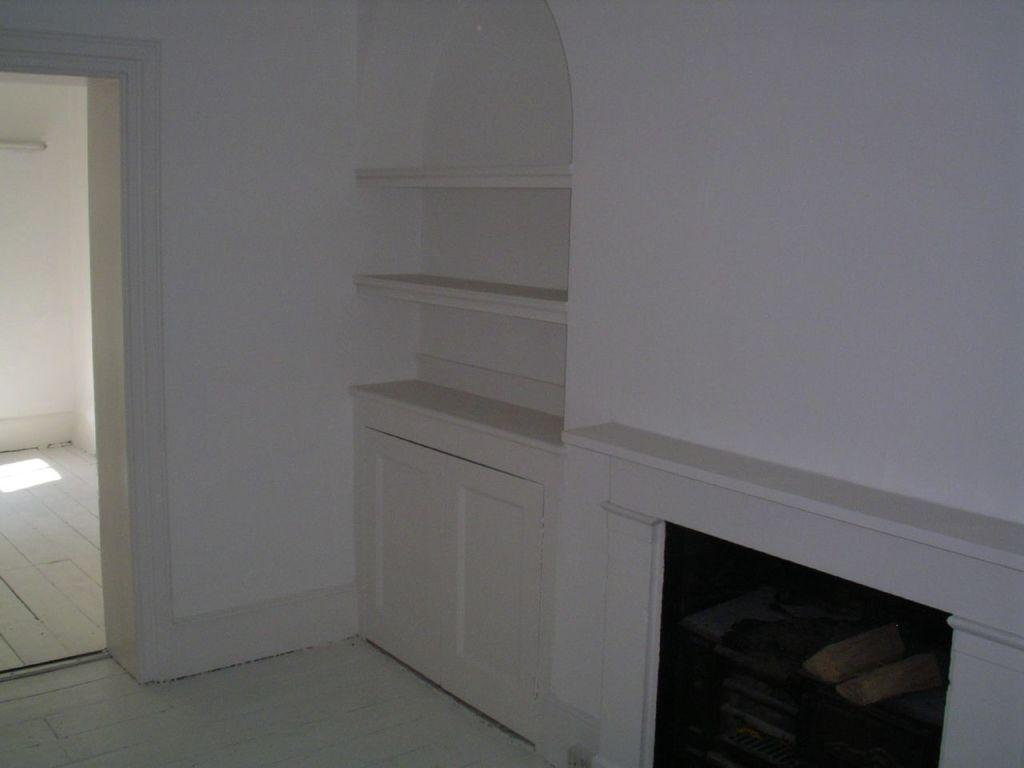What type of structure is present in the image? There is a wall in the image. What color is the wall? The wall is white in color. What can be seen attached to the wall? There are shelves in the image. How does the wall help with the education of the birds in the image? There are no birds present in the image, and the wall is not associated with any educational activities. 